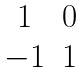<formula> <loc_0><loc_0><loc_500><loc_500>\begin{matrix} 1 & 0 \\ - 1 & 1 \end{matrix}</formula> 